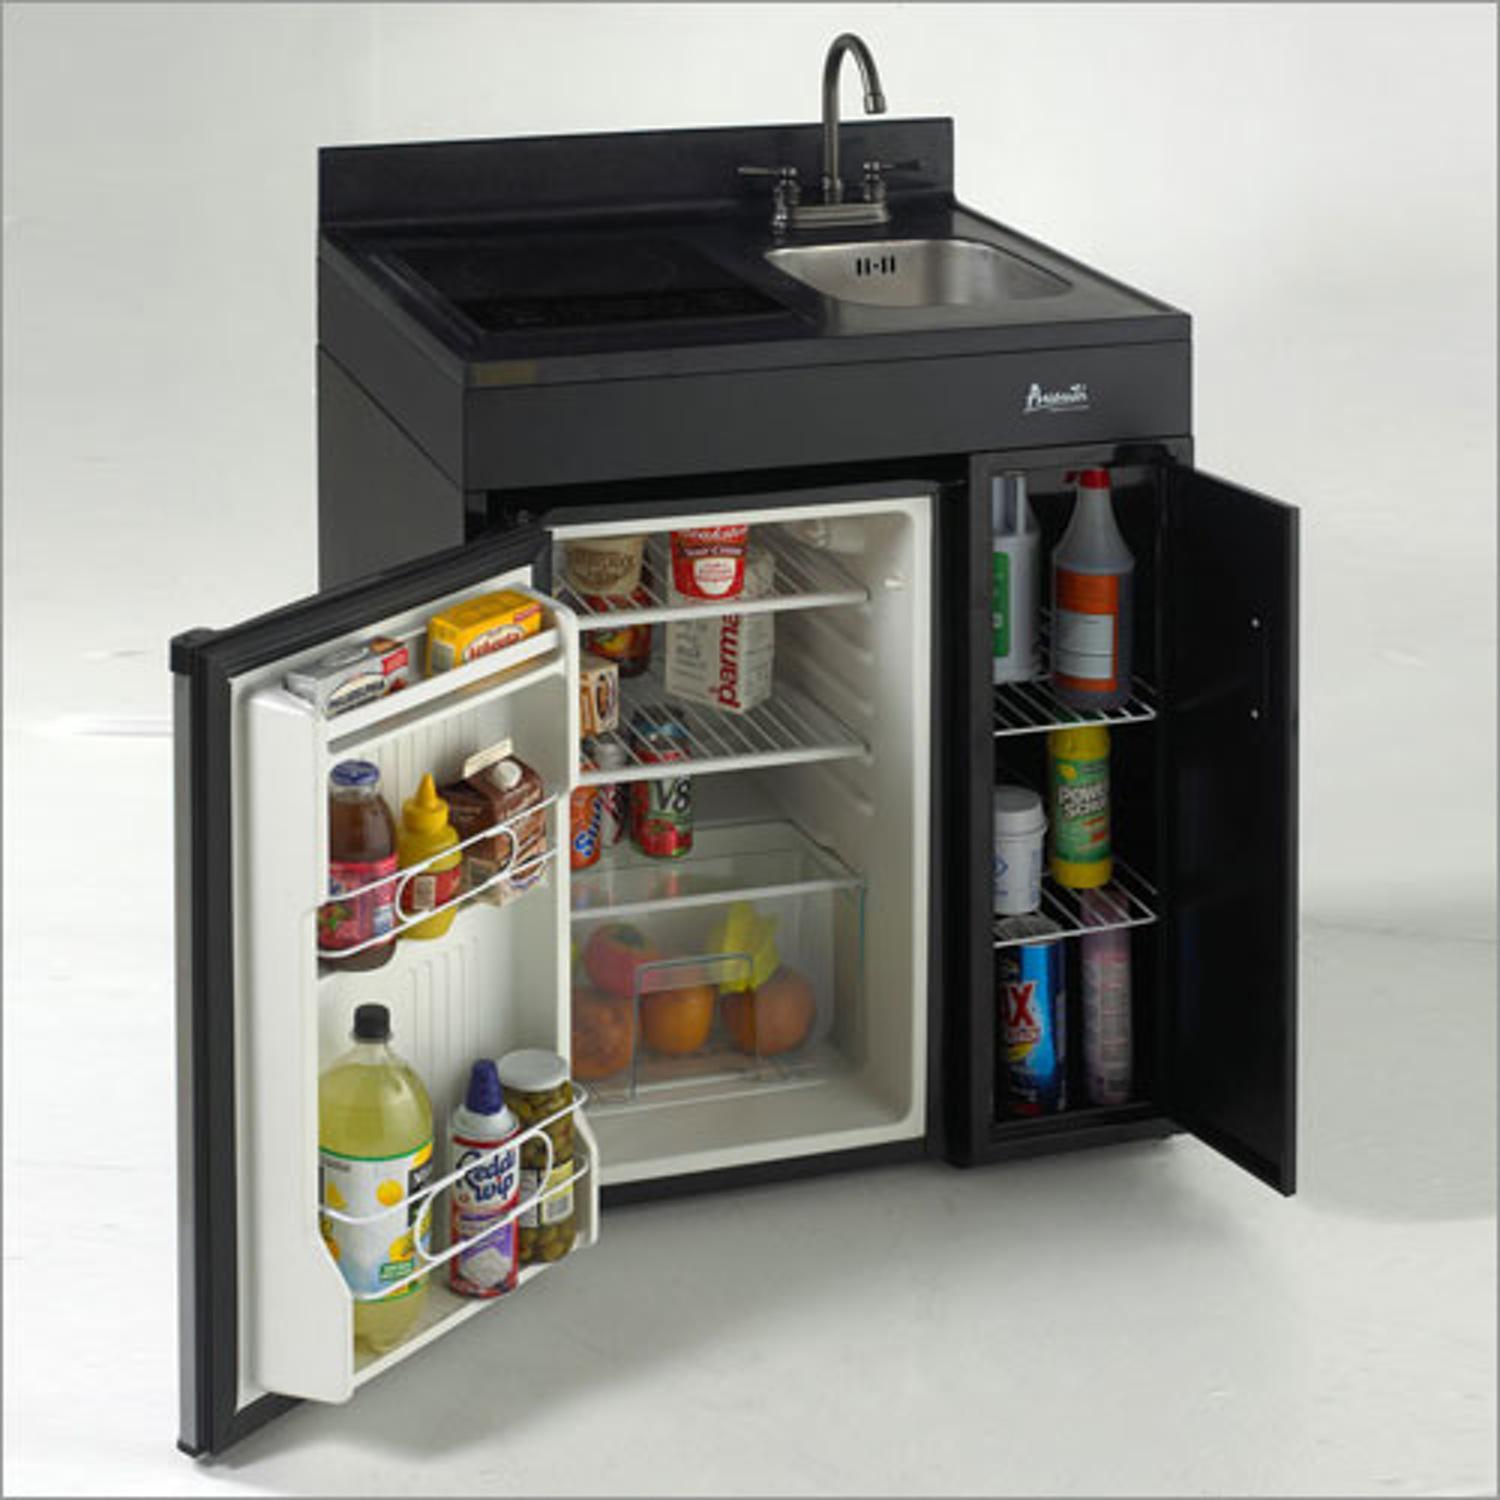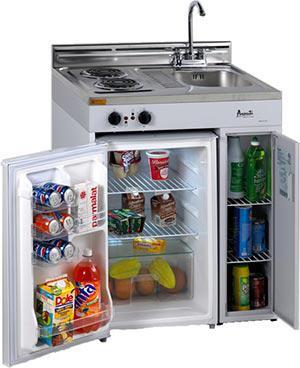The first image is the image on the left, the second image is the image on the right. Given the left and right images, does the statement "In at least one image there is a small fridge that door is open to the right." hold true? Answer yes or no. No. The first image is the image on the left, the second image is the image on the right. Analyze the images presented: Is the assertion "Both refrigerators have a side compartment." valid? Answer yes or no. Yes. 